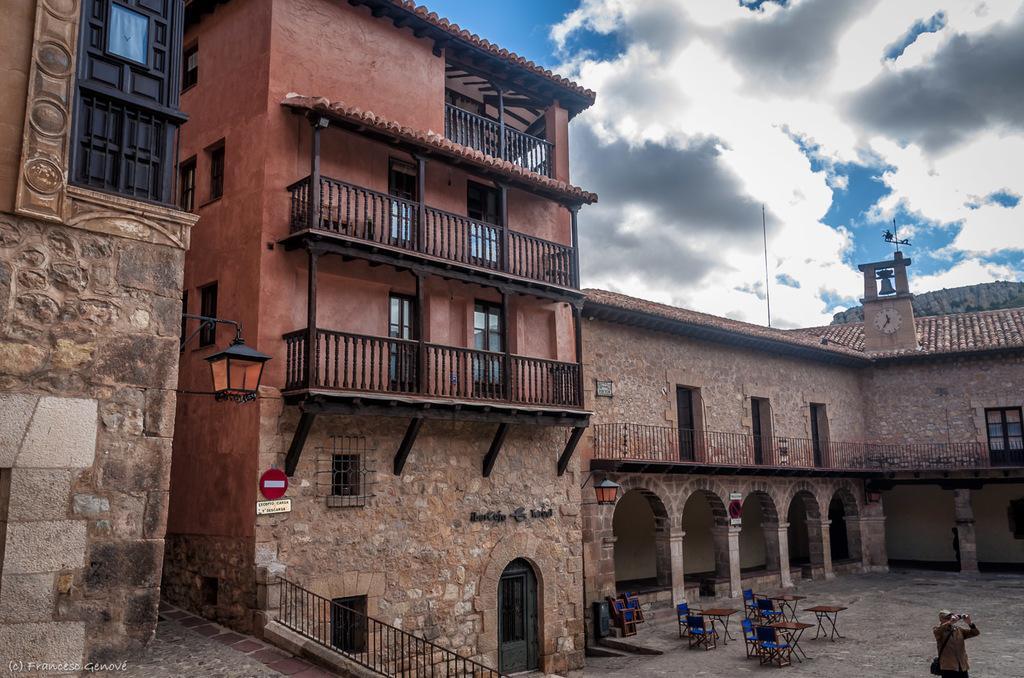Can you describe this image briefly? In this image in the center there are some buildings, and at the bottom there are some tables and chairs and one person is standing and he is holding a camera. And in the center there is one light and some boards, on the right side there is one clock. At the top of the image there is sky. 